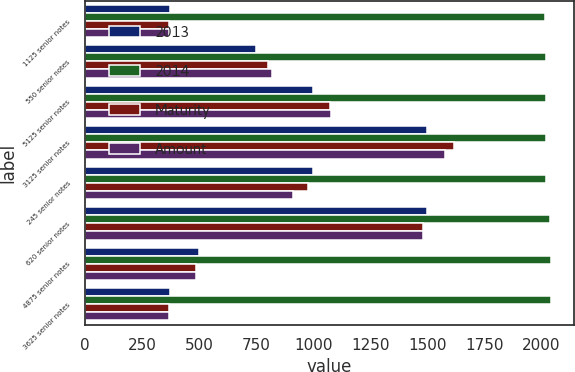Convert chart to OTSL. <chart><loc_0><loc_0><loc_500><loc_500><stacked_bar_chart><ecel><fcel>1125 senior notes<fcel>550 senior notes<fcel>5125 senior notes<fcel>3125 senior notes<fcel>245 senior notes<fcel>620 senior notes<fcel>4875 senior notes<fcel>3625 senior notes<nl><fcel>2013<fcel>375<fcel>750<fcel>1000<fcel>1500<fcel>1000<fcel>1500<fcel>500<fcel>375<nl><fcel>2014<fcel>2017<fcel>2018<fcel>2019<fcel>2021<fcel>2022<fcel>2038<fcel>2040<fcel>2042<nl><fcel>Maturity<fcel>370<fcel>802<fcel>1076<fcel>1617<fcel>977<fcel>1481<fcel>489<fcel>367<nl><fcel>Amount<fcel>367<fcel>821<fcel>1079<fcel>1579<fcel>913<fcel>1481<fcel>489<fcel>367<nl></chart> 